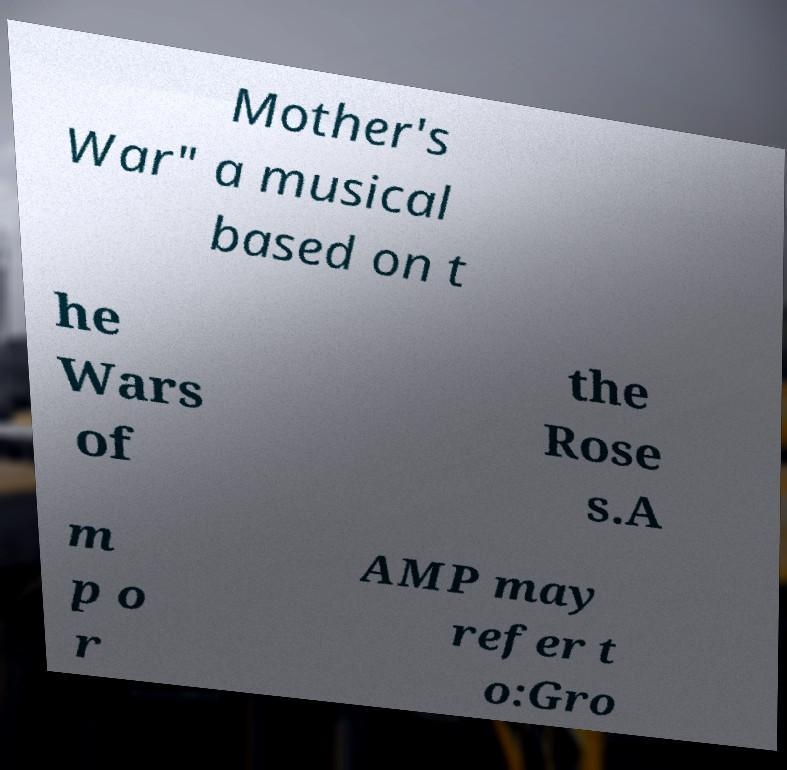Please read and relay the text visible in this image. What does it say? Mother's War" a musical based on t he Wars of the Rose s.A m p o r AMP may refer t o:Gro 